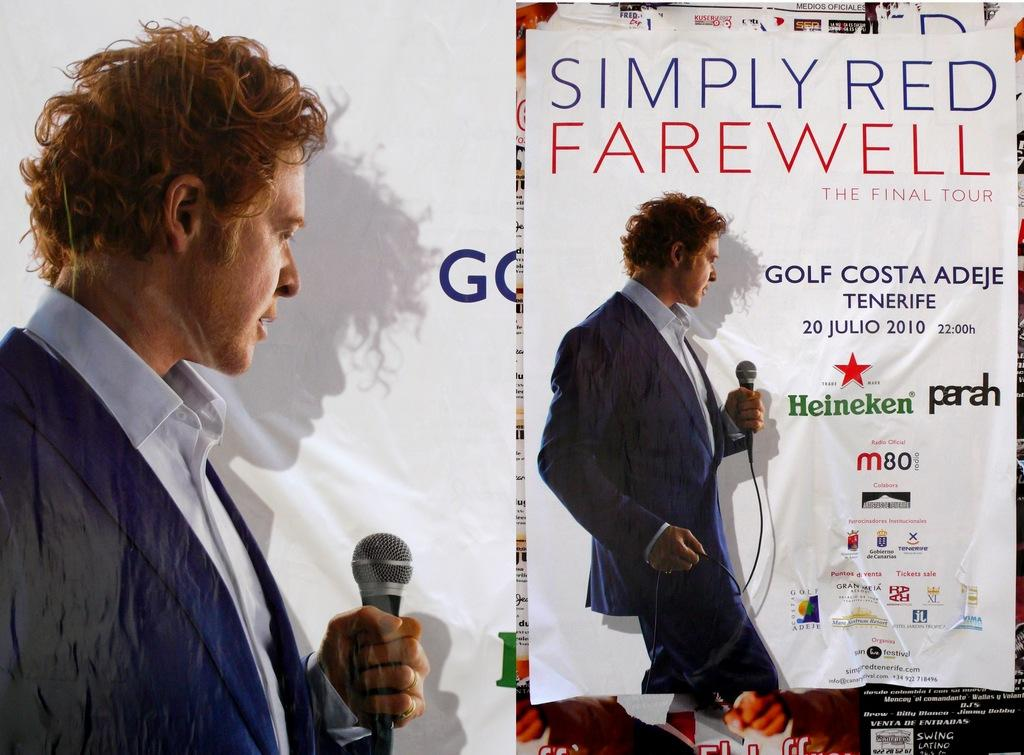What is depicted on the poster in the image? The poster features a person in the image. What is the person holding in the poster? The person is holding a microphone in the poster. What position is the person in on the poster? The person is standing on the poster. How many cows can be seen grazing in the background of the poster? There are no cows visible in the image or the poster; it only features a person holding a microphone. 